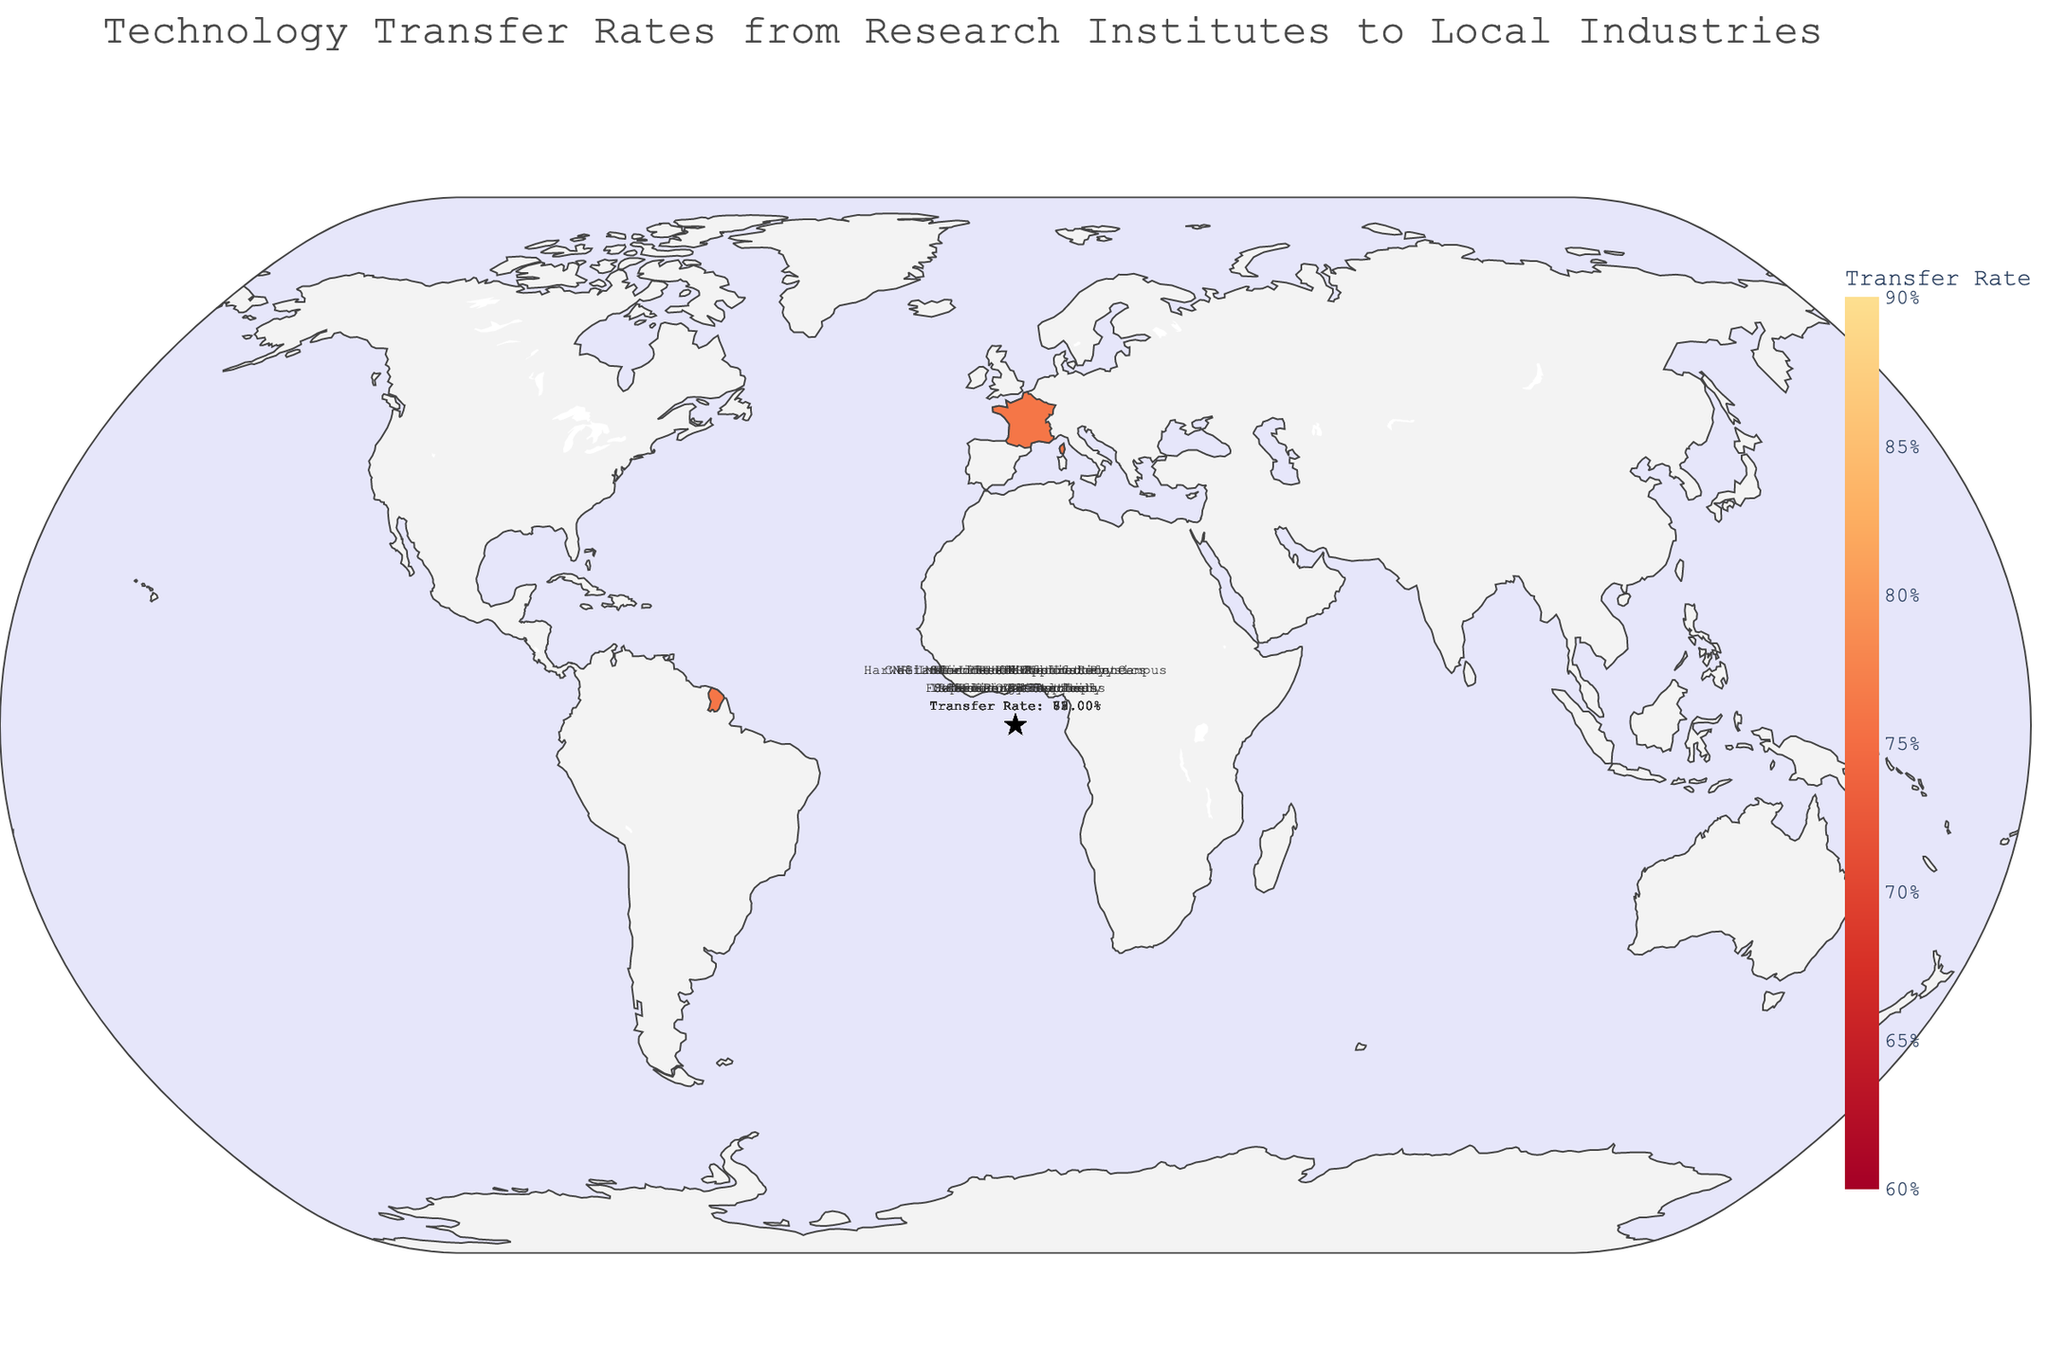What's the title of the figure? The title is usually located at the top of the figure and provides a summary of what the figure represents. In this case, it states "Technology Transfer Rates from Research Institutes to Local Industries".
Answer: Technology Transfer Rates from Research Institutes to Local Industries Which region has the highest technology transfer rate? To identify the highest transfer rate, we compare all the rates displayed on the figure. Tel Aviv is highlighted as having the highest rate at 0.82.
Answer: Tel Aviv What is the technology transfer rate from the Perimeter Institute to Canadian AI Startups? The transfer rate can be directly read from the figure by identifying the specific data point for the Perimeter Institute in Ontario. The rate mentioned is 0.73.
Answer: 0.73 Which industries are supported by institutes in Europe? To identify the industries in Europe, look for the regions marked in Europe and check the institutes and industries associated. Bavaria (German Automotive), Lombardy (Italian Aerospace), Île-de-France (French Pharmaceuticals), Oxfordshire (UK Energy Sector), and Zürich (Swiss Financial Tech) are listed.
Answer: German Automotive, Italian Aerospace, French Pharmaceuticals, UK Energy Sector, Swiss Financial Tech What is the average technology transfer rate across all regions? Calculate the average by summing up all transfer rates and dividing by the number of regions: (0.85 + 0.78 + 0.72 + 0.81 + 0.65 + 0.76 + 0.69 + 0.77 + 0.73 + 0.82) / 10 = 7.58 / 10 = 0.758.
Answer: 0.758 Which region has the lowest technology transfer rate and what is the industry it supports? To find the lowest transfer rate, look for the lowest value in the figure. Lombardy has the lowest rate at 0.65, supporting the Italian Aerospace industry.
Answer: Lombardy, Italian Aerospace Which regions have a technology transfer rate higher than 0.80? Identify all regions where the transfer rate exceeds 0.80. The regions highlighted are California (0.85), Tokyo (0.81), and Tel Aviv (0.82).
Answer: California, Tokyo, Tel Aviv How does the transfer rate for the Max Planck Institute compare to ETH Zurich? Compare the transfer rates of the two institutes. Max Planck Institute has a transfer rate of 0.72, while ETH Zurich has a rate of 0.77. ETH Zurich has a higher rate.
Answer: ETH Zurich has a higher rate What is the range of technology transfer rates shown on the figure? The range can be determined by subtracting the smallest transfer rate from the largest. The smallest rate is 0.65 (Lombardy) and the largest is 0.85 (California). So, the range is 0.85 - 0.65 = 0.20.
Answer: 0.20 Of the regions listed, how many have technology transfer rates above the average rate? First, find the average rate (0.758). Then, count the number of regions with rates above this average: California (0.85), Tokyo (0.81), Tel Aviv (0.82), Massachusetts (0.78), Zürich (0.77), and Île-de-France (0.76) make a total of 6 regions.
Answer: 6 regions 